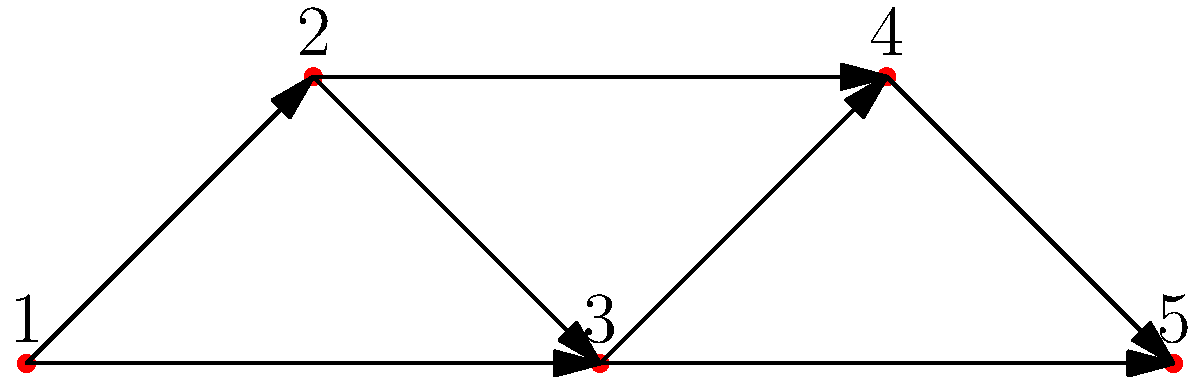In the directed graph representing fashion influence flow, vertices represent key players (1: Celebrity, 2: Designer, 3: Influencer, 4: Retailer, 5: Consumer). Edges represent the direction of influence. What is the minimum number of edges that need to be removed to disconnect the Consumer (vertex 5) from the Celebrity (vertex 1)? To solve this problem, we need to find the minimum cut between vertex 1 (Celebrity) and vertex 5 (Consumer). We can do this by following these steps:

1. Identify all paths from Celebrity (1) to Consumer (5):
   Path 1: 1 → 2 → 3 → 4 → 5
   Path 2: 1 → 2 → 4 → 5
   Path 3: 1 → 3 → 4 → 5

2. Observe that all paths must go through either edge 2→4 or 3→4 to reach the Consumer.

3. Removing both edges 2→4 and 3→4 would disconnect all paths from Celebrity to Consumer.

4. Check if removing only one of these edges is sufficient:
   - If we remove only 2→4, Path 3 still exists.
   - If we remove only 3→4, Path 2 still exists.

5. Therefore, we need to remove both edges 2→4 and 3→4 to disconnect the Consumer from the Celebrity.

The minimum number of edges to remove is 2.
Answer: 2 